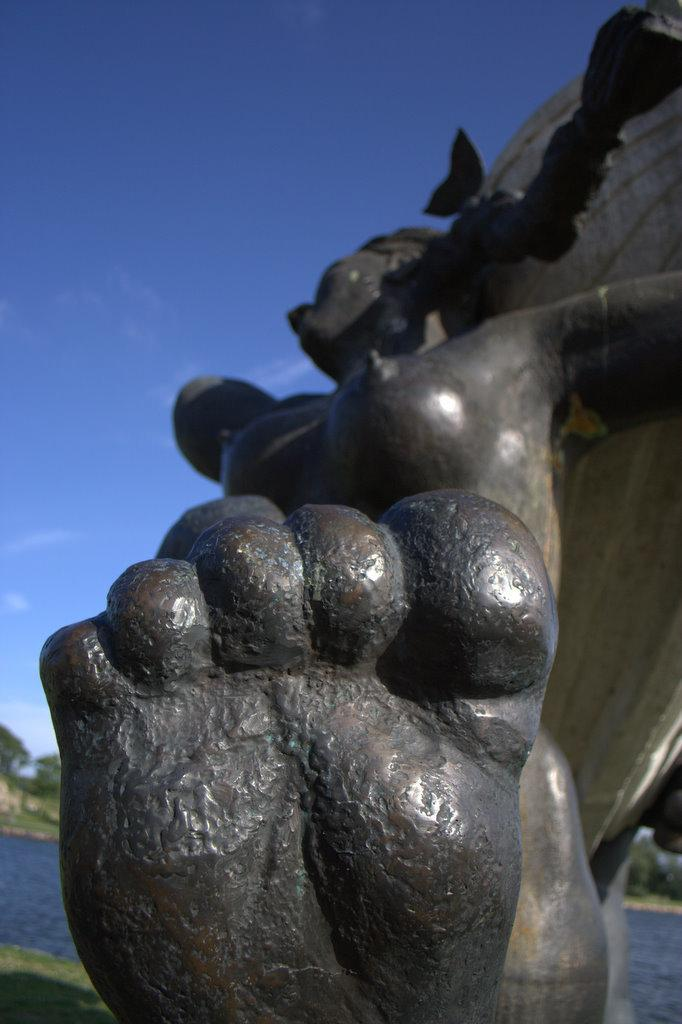What is the main subject in the image? There is a statue in the image. What can be seen in the background of the image? The sky is visible at the top of the image. What is located on the left bottom of the image? There is a water body on the left bottom of the image. How many brothers are depicted with the statue in the image? There are no brothers depicted with the statue in the image. What type of sack is being used by the statue in the image? There is no sack present in the image; it features a statue and a water body. 